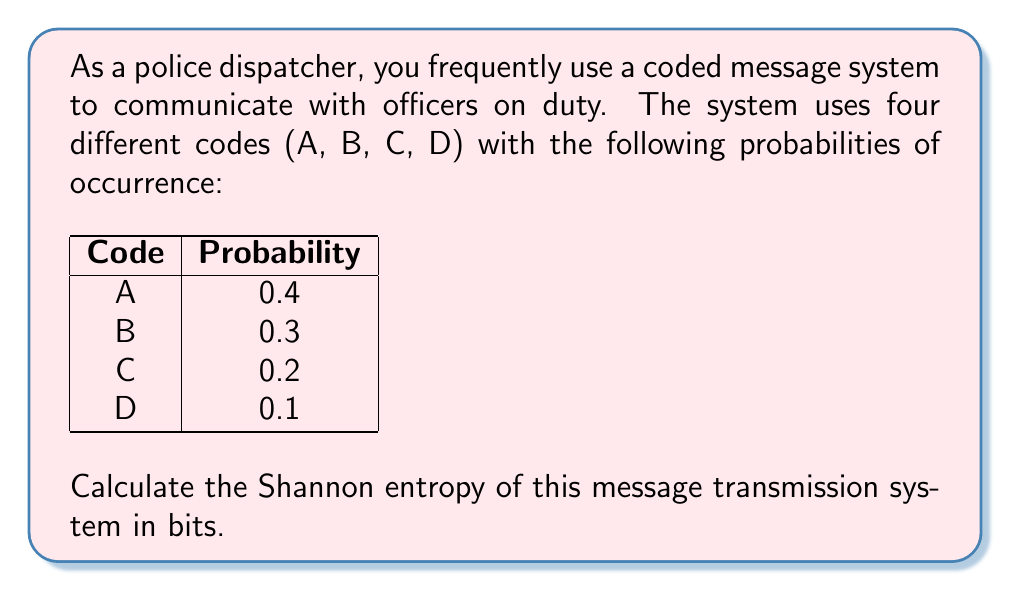Solve this math problem. To calculate the Shannon entropy of the message transmission system, we'll follow these steps:

1) The Shannon entropy formula is:
   $$H = -\sum_{i=1}^n p_i \log_2(p_i)$$
   where $p_i$ is the probability of each symbol, and $n$ is the number of symbols.

2) We have four codes with their respective probabilities:
   $p_A = 0.4$, $p_B = 0.3$, $p_C = 0.2$, $p_D = 0.1$

3) Let's calculate each term separately:
   
   For A: $-0.4 \log_2(0.4) = 0.528321$
   For B: $-0.3 \log_2(0.3) = 0.521015$
   For C: $-0.2 \log_2(0.2) = 0.464386$
   For D: $-0.1 \log_2(0.1) = 0.332193$

4) Now, we sum all these terms:
   
   $H = 0.528321 + 0.521015 + 0.464386 + 0.332193 = 1.845915$

5) Therefore, the Shannon entropy of the system is approximately 1.846 bits.
Answer: 1.846 bits 